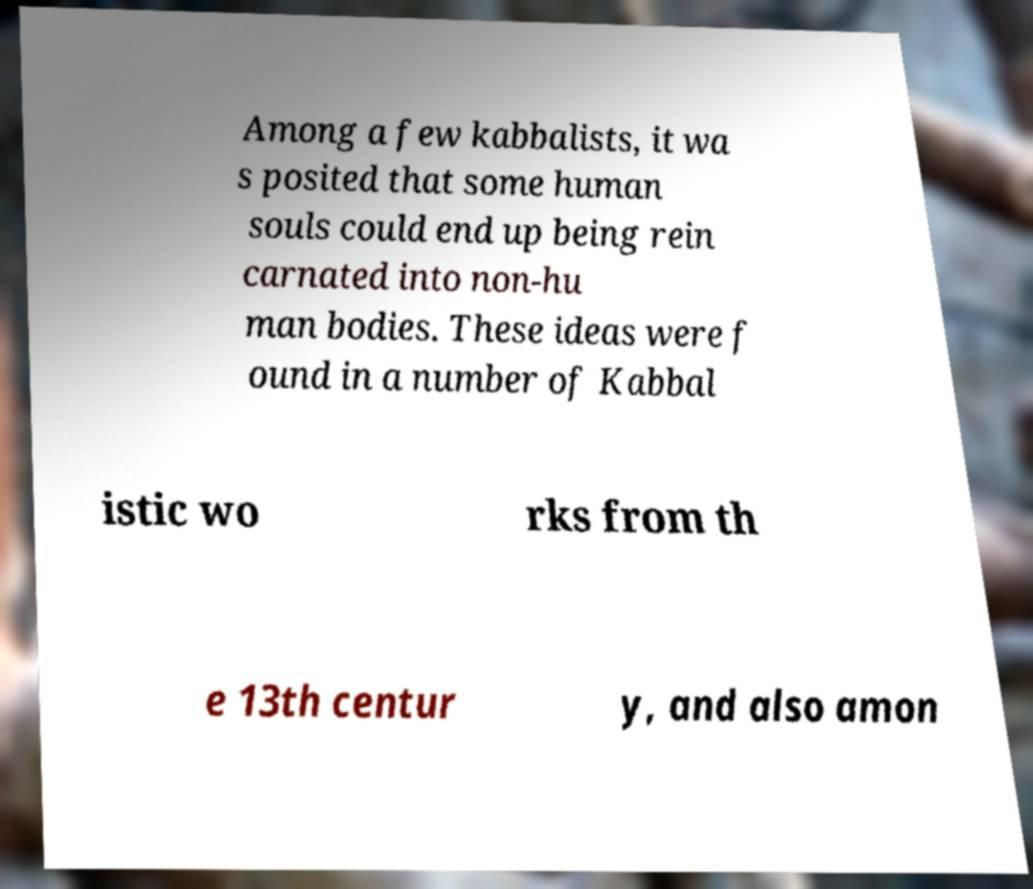Could you extract and type out the text from this image? Among a few kabbalists, it wa s posited that some human souls could end up being rein carnated into non-hu man bodies. These ideas were f ound in a number of Kabbal istic wo rks from th e 13th centur y, and also amon 